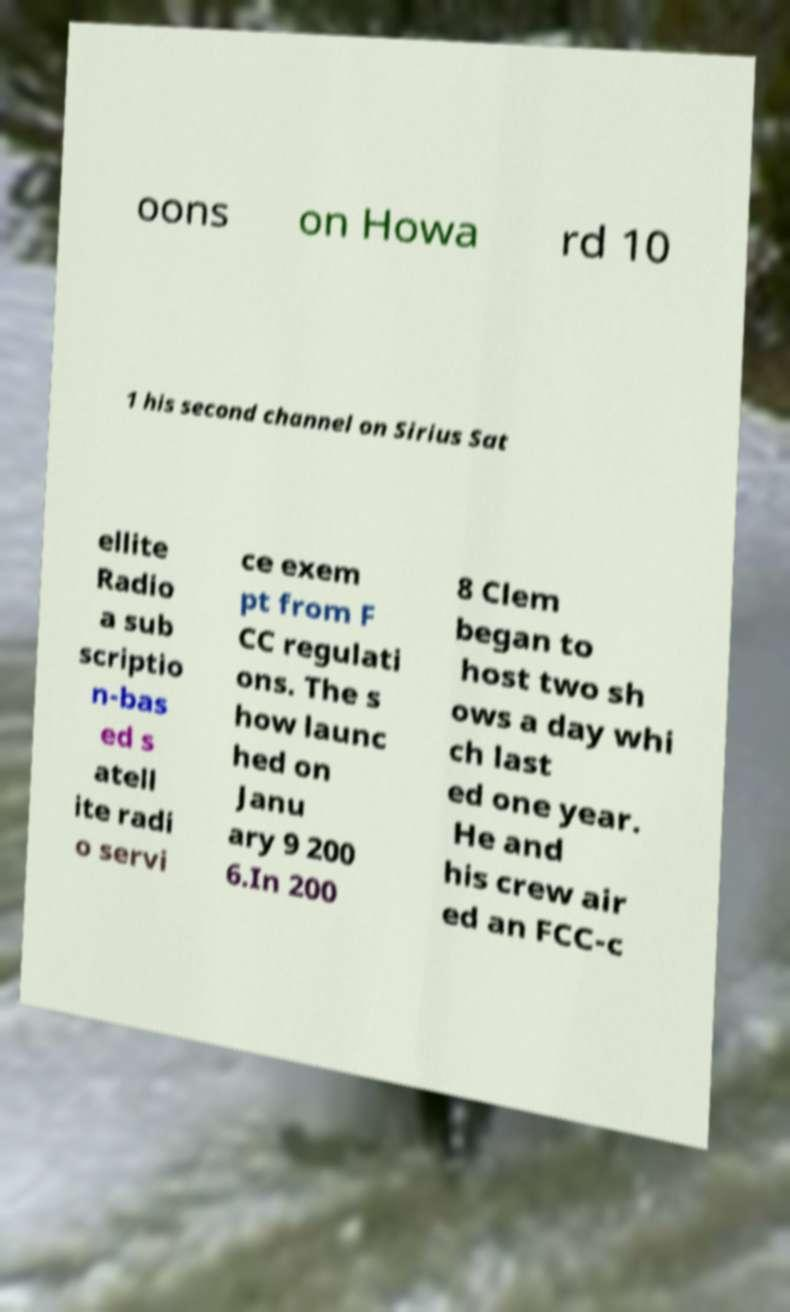Please identify and transcribe the text found in this image. oons on Howa rd 10 1 his second channel on Sirius Sat ellite Radio a sub scriptio n-bas ed s atell ite radi o servi ce exem pt from F CC regulati ons. The s how launc hed on Janu ary 9 200 6.In 200 8 Clem began to host two sh ows a day whi ch last ed one year. He and his crew air ed an FCC-c 